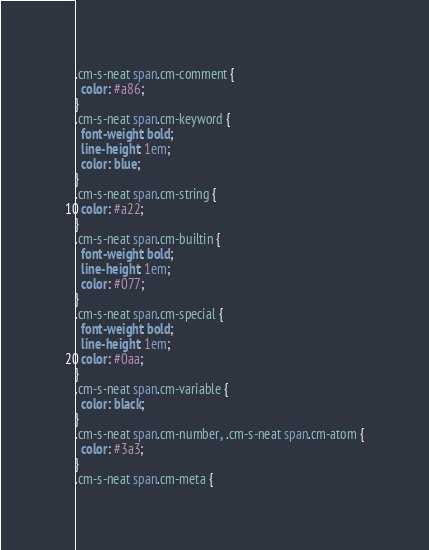Convert code to text. <code><loc_0><loc_0><loc_500><loc_500><_CSS_>.cm-s-neat span.cm-comment {
  color: #a86;
}
.cm-s-neat span.cm-keyword {
  font-weight: bold;
  line-height: 1em;
  color: blue;
}
.cm-s-neat span.cm-string {
  color: #a22;
}
.cm-s-neat span.cm-builtin {
  font-weight: bold;
  line-height: 1em;
  color: #077;
}
.cm-s-neat span.cm-special {
  font-weight: bold;
  line-height: 1em;
  color: #0aa;
}
.cm-s-neat span.cm-variable {
  color: black;
}
.cm-s-neat span.cm-number, .cm-s-neat span.cm-atom {
  color: #3a3;
}
.cm-s-neat span.cm-meta {</code> 